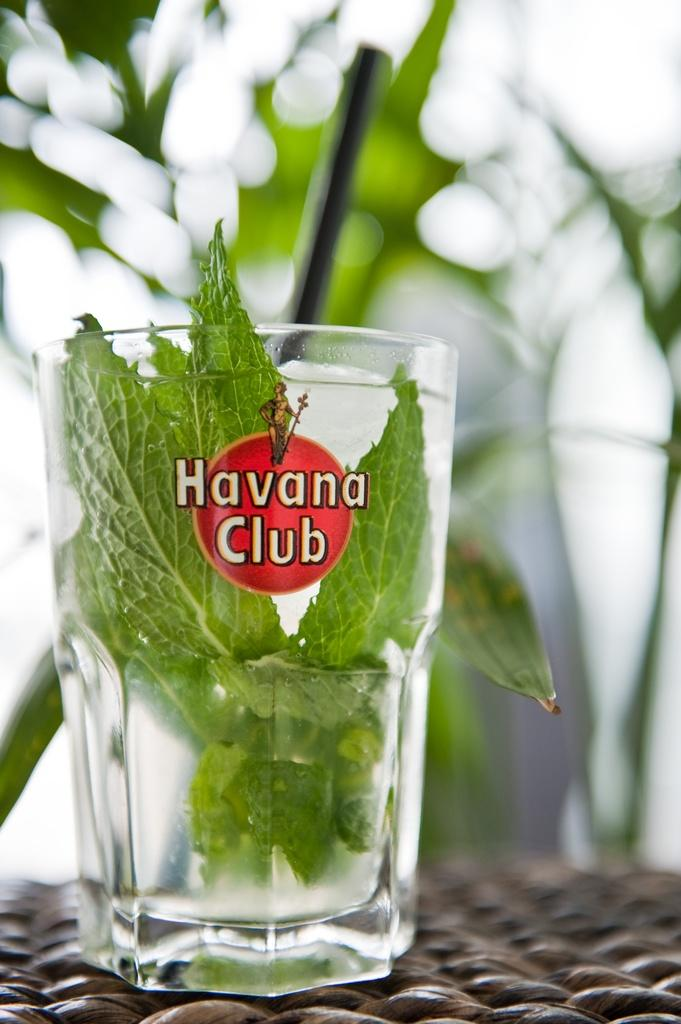What object is present in the image that can hold liquid? There is a glass in the image. Where is the glass located? The glass is placed on a platform. What is inside the glass? There is water in the glass. What is floating in the water? There are leaves in the water. What can be seen in the background of the image? There are trees in the background of the image. How would you describe the background of the image? The background is blurry. What type of polish is being applied to the leaves in the image? There is no indication in the image that any polish is being applied to the leaves; they are simply floating in the water. How does the rainstorm affect the glass in the image? There is no rainstorm present in the image, so its effect on the glass cannot be determined. 